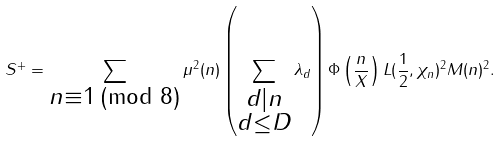Convert formula to latex. <formula><loc_0><loc_0><loc_500><loc_500>S ^ { + } = \sum _ { \substack { n \equiv 1 \, ( \text {mod } 8 ) } } \mu ^ { 2 } ( n ) \left ( \sum _ { \substack { d | n \\ d \leq D } } \lambda _ { d } \right ) \Phi \left ( \frac { n } { X } \right ) L ( \frac { 1 } { 2 } , \chi _ { n } ) ^ { 2 } M ( n ) ^ { 2 } .</formula> 